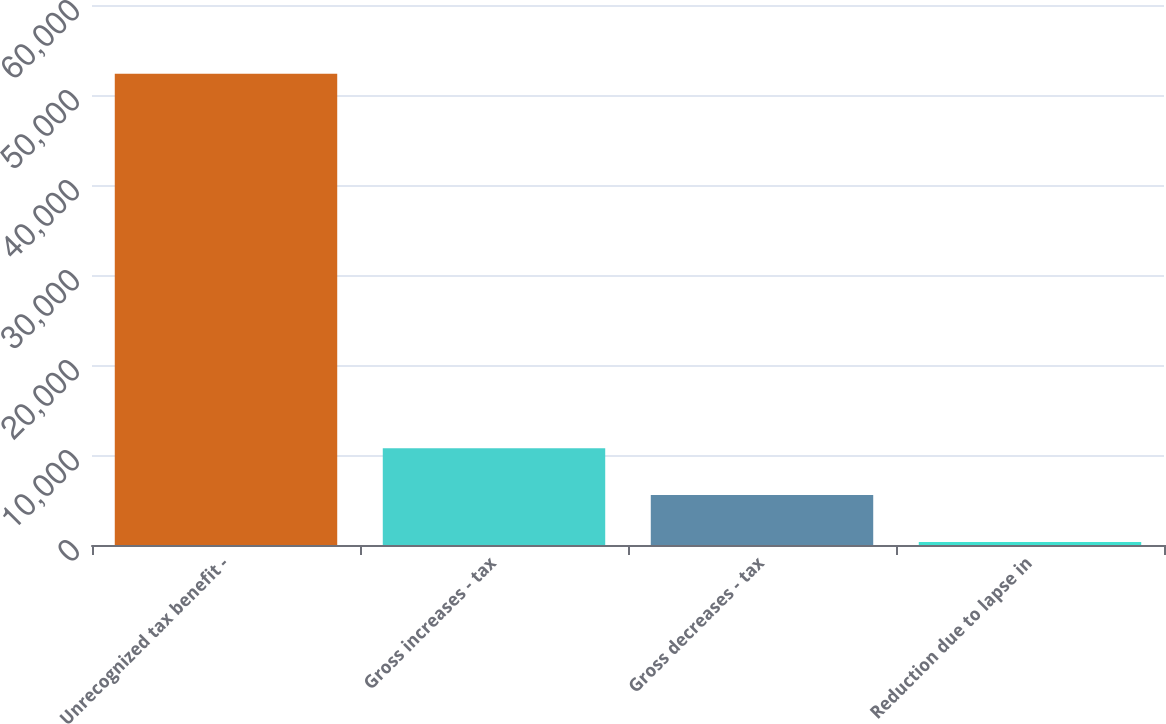<chart> <loc_0><loc_0><loc_500><loc_500><bar_chart><fcel>Unrecognized tax benefit -<fcel>Gross increases - tax<fcel>Gross decreases - tax<fcel>Reduction due to lapse in<nl><fcel>52356<fcel>10748<fcel>5547<fcel>346<nl></chart> 